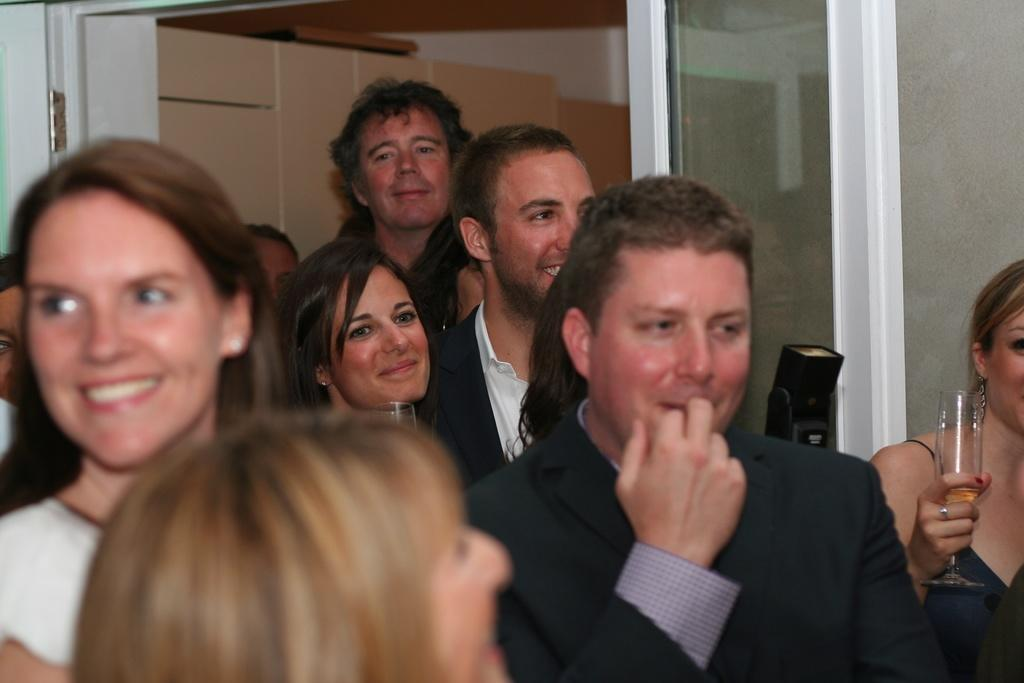How many people are in the image? There are persons standing in the image. What is one person holding in the image? One person is holding a glass. What can be seen in the background of the image? There is a wall visible in the background of the image. What type of vein is visible in the image? There is no vein visible in the image. Can you hear a bell ringing in the image? There is no bell present in the image, so it cannot be heard. 